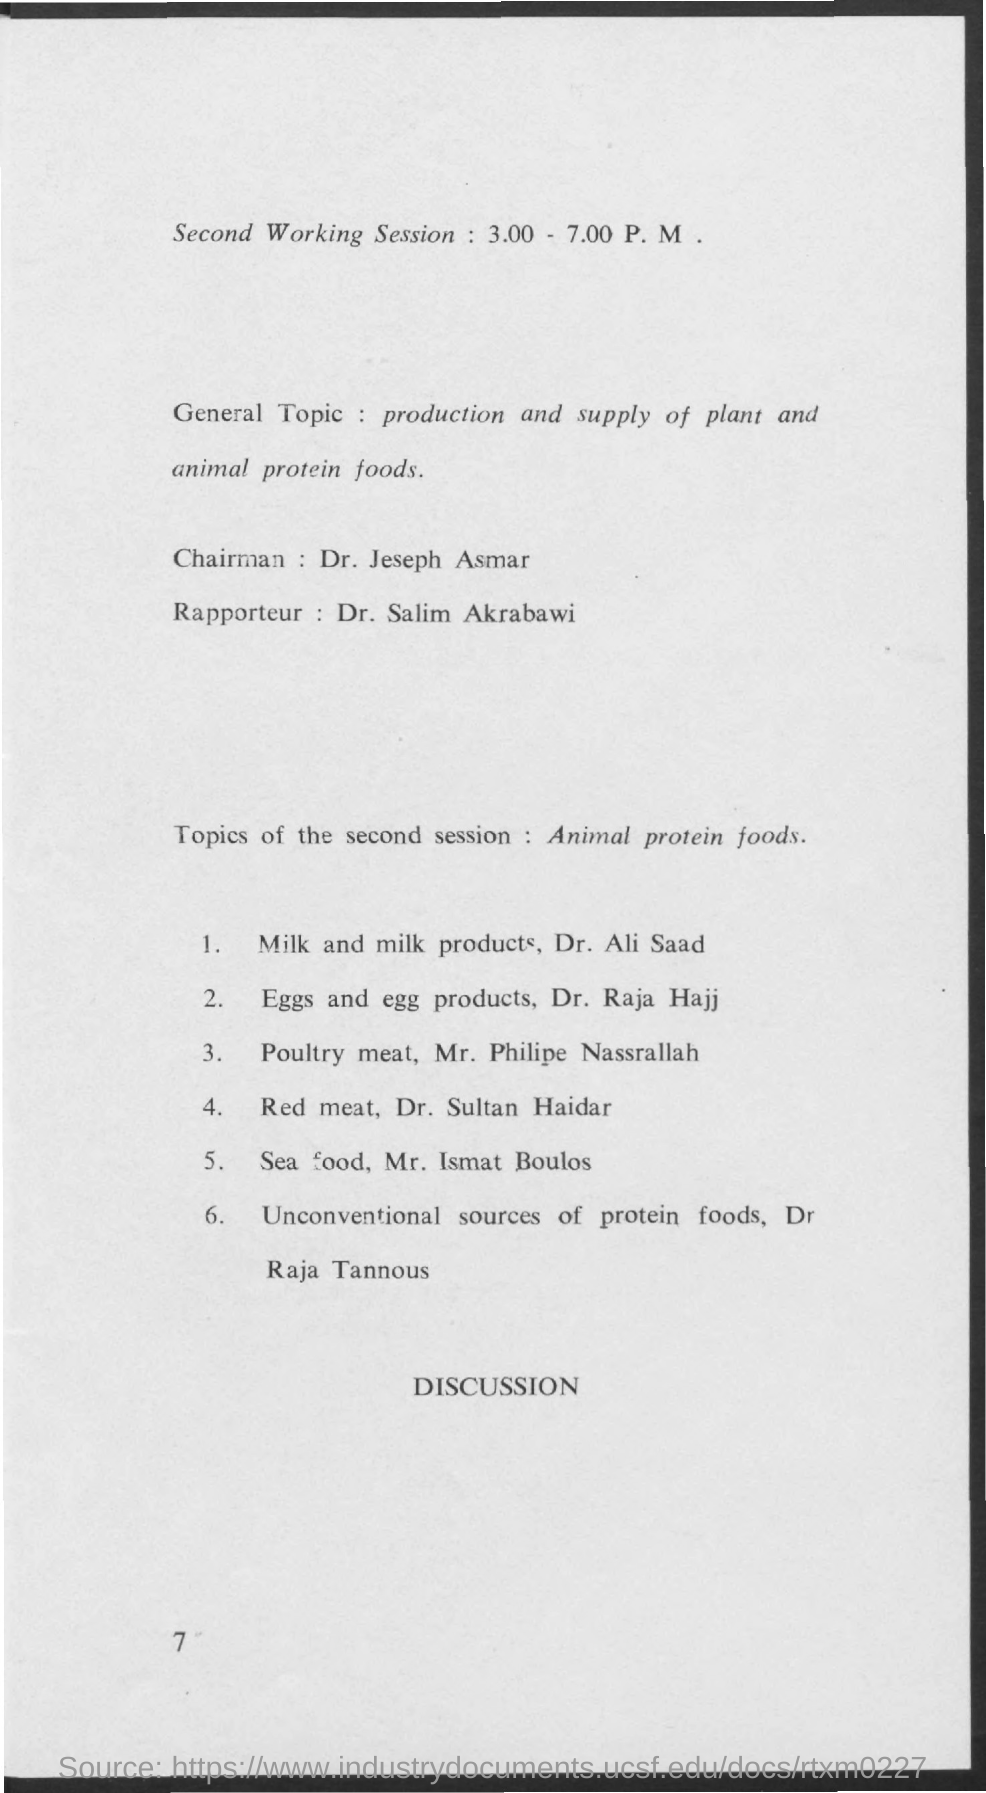Outline some significant characteristics in this image. Joseph Asmar is the Chairman. 